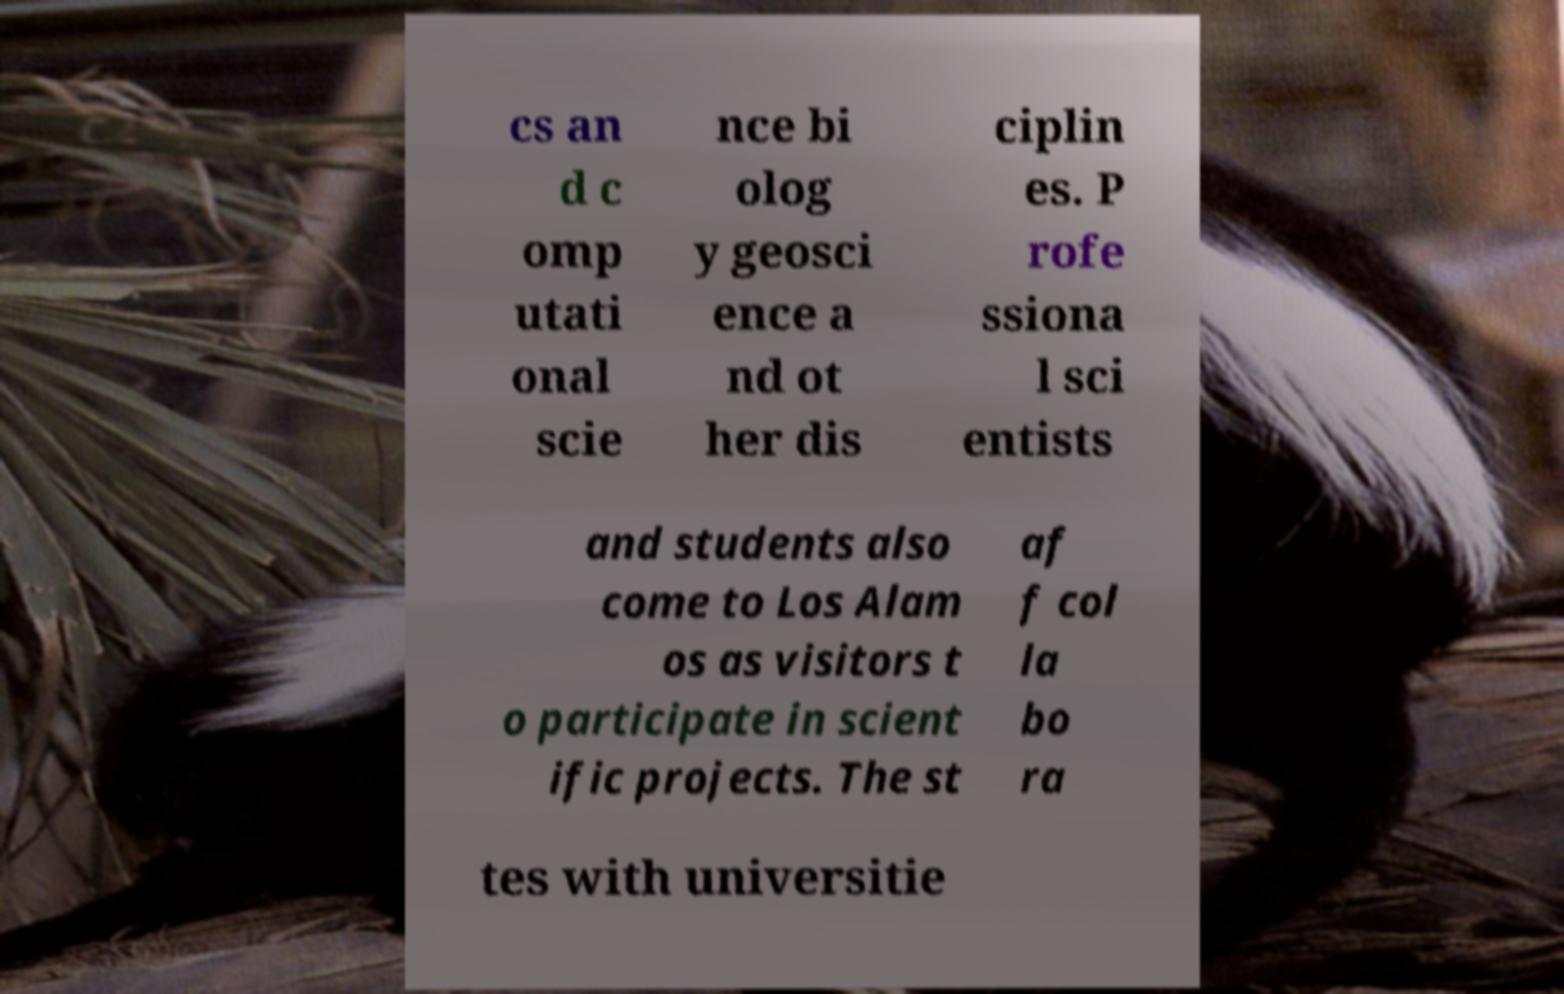Could you assist in decoding the text presented in this image and type it out clearly? cs an d c omp utati onal scie nce bi olog y geosci ence a nd ot her dis ciplin es. P rofe ssiona l sci entists and students also come to Los Alam os as visitors t o participate in scient ific projects. The st af f col la bo ra tes with universitie 